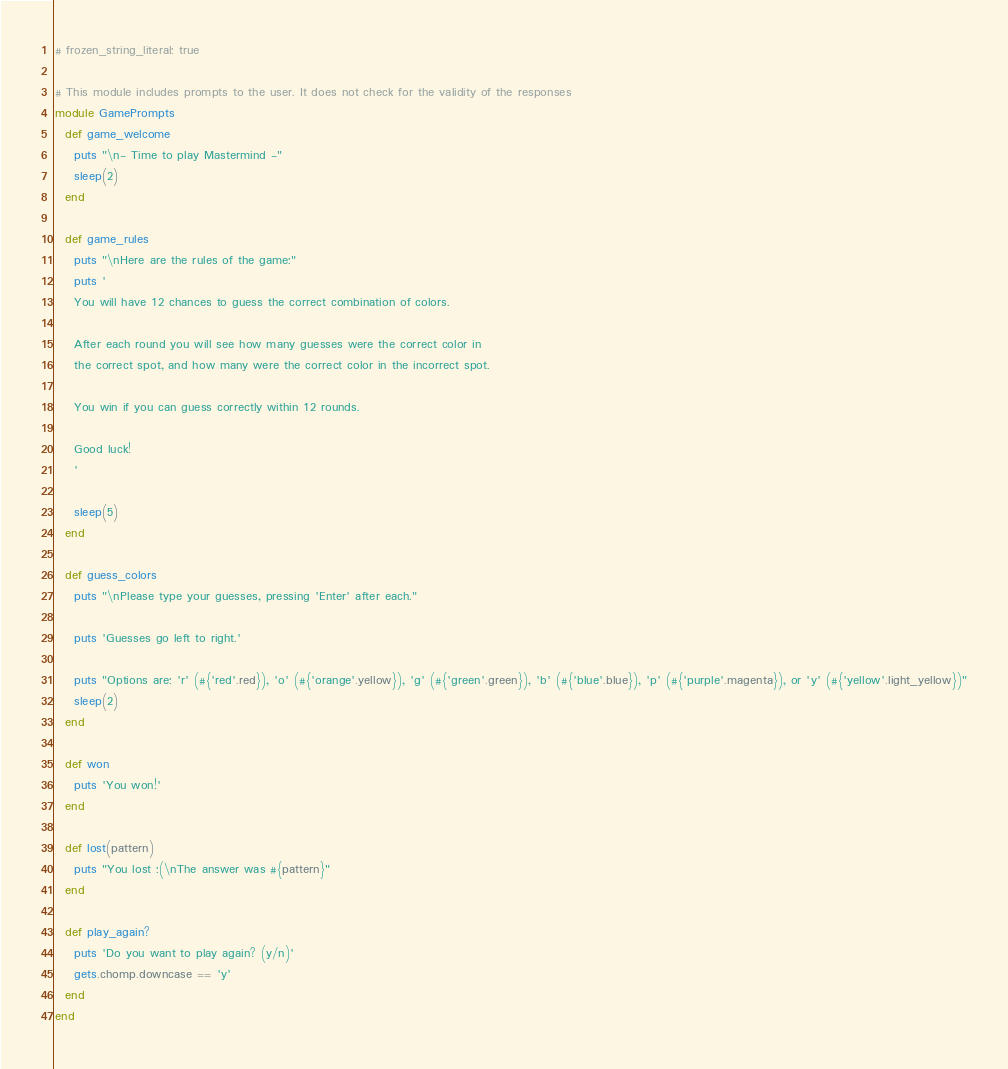<code> <loc_0><loc_0><loc_500><loc_500><_Ruby_># frozen_string_literal: true

# This module includes prompts to the user. It does not check for the validity of the responses
module GamePrompts
  def game_welcome
    puts "\n- Time to play Mastermind -"
    sleep(2)
  end

  def game_rules
    puts "\nHere are the rules of the game:"
    puts '
    You will have 12 chances to guess the correct combination of colors.

    After each round you will see how many guesses were the correct color in
    the correct spot, and how many were the correct color in the incorrect spot.

    You win if you can guess correctly within 12 rounds.

    Good luck!
    '

    sleep(5)
  end

  def guess_colors
    puts "\nPlease type your guesses, pressing 'Enter' after each."

    puts 'Guesses go left to right.'

    puts "Options are: 'r' (#{'red'.red}), 'o' (#{'orange'.yellow}), 'g' (#{'green'.green}), 'b' (#{'blue'.blue}), 'p' (#{'purple'.magenta}), or 'y' (#{'yellow'.light_yellow})"
    sleep(2)
  end

  def won
    puts 'You won!'
  end

  def lost(pattern)
    puts "You lost :(\nThe answer was #{pattern}"
  end

  def play_again?
    puts 'Do you want to play again? (y/n)'
    gets.chomp.downcase == 'y'
  end
end
</code> 